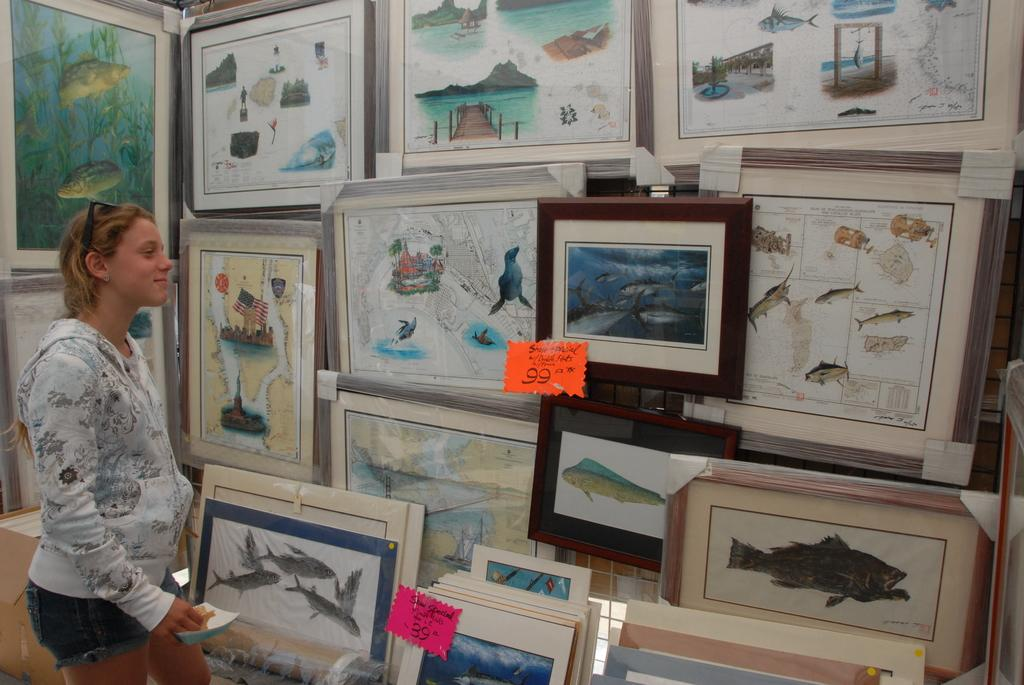Who is present in the picture? There is a woman in the picture. What can be seen hanging on the wall in the picture? There are photo frames in the picture. What type of decorative items are visible in the picture? There are stickers in the picture. Can you describe any other objects visible in the picture? There are other objects visible in the picture, but their specific details are not mentioned in the provided facts. What type of quiver is the woman holding in the picture? There is no quiver present in the picture; it features a woman, photo frames, and stickers. 